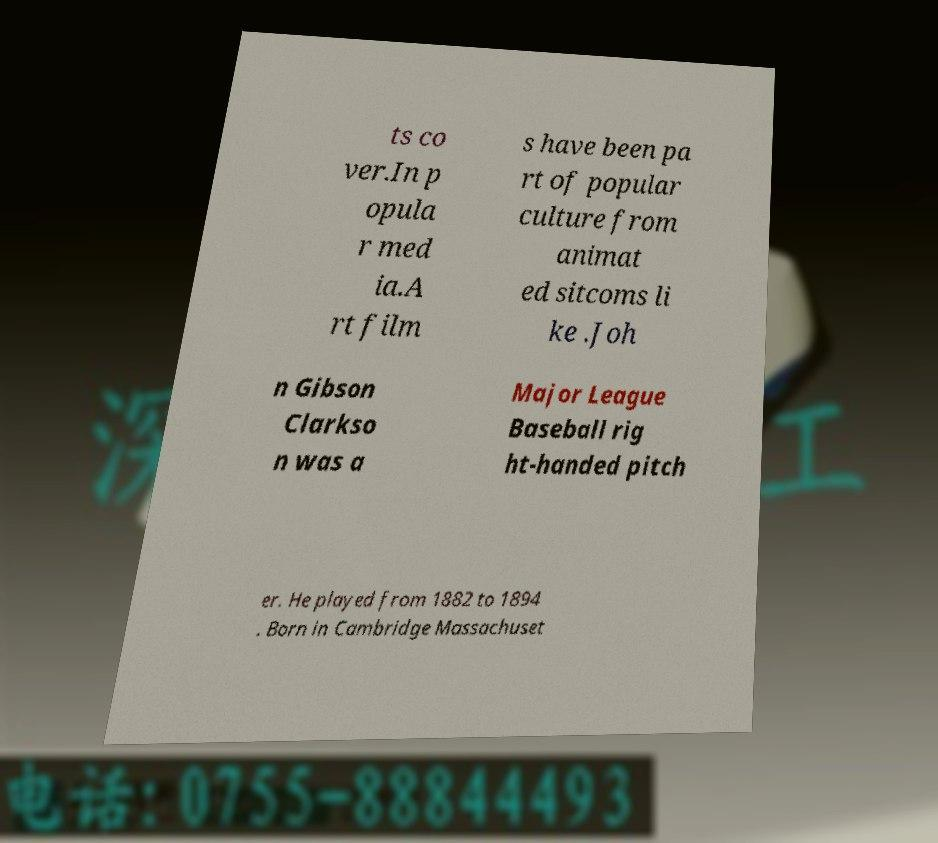Can you accurately transcribe the text from the provided image for me? ts co ver.In p opula r med ia.A rt film s have been pa rt of popular culture from animat ed sitcoms li ke .Joh n Gibson Clarkso n was a Major League Baseball rig ht-handed pitch er. He played from 1882 to 1894 . Born in Cambridge Massachuset 